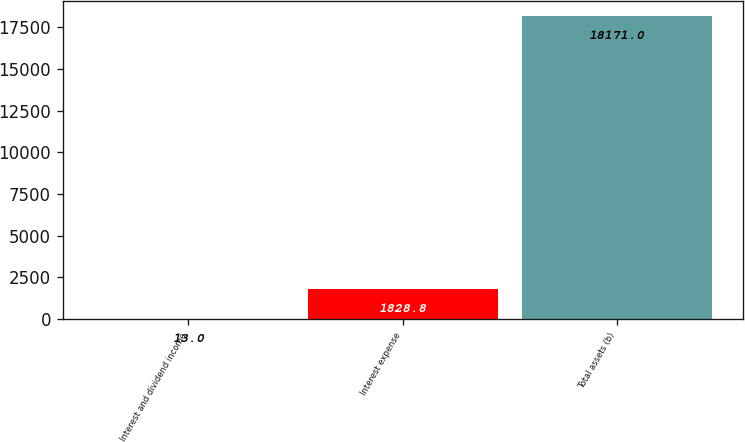Convert chart to OTSL. <chart><loc_0><loc_0><loc_500><loc_500><bar_chart><fcel>Interest and dividend income<fcel>Interest expense<fcel>Total assets (b)<nl><fcel>13<fcel>1828.8<fcel>18171<nl></chart> 